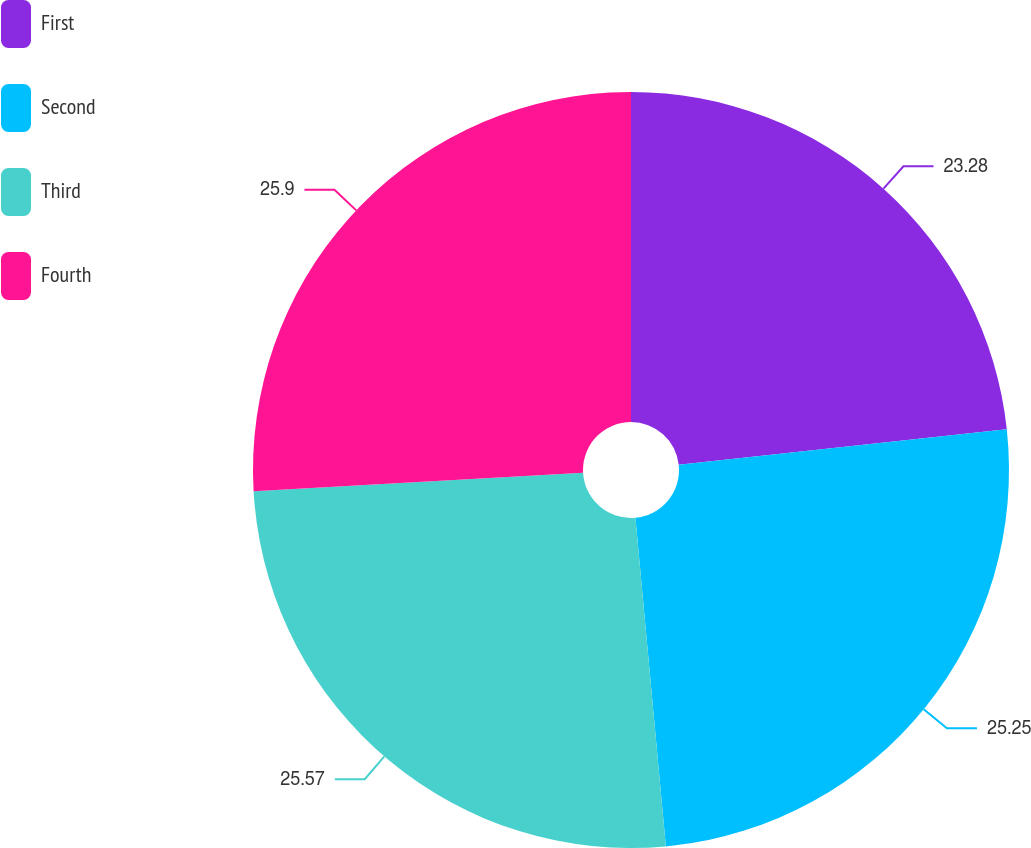Convert chart to OTSL. <chart><loc_0><loc_0><loc_500><loc_500><pie_chart><fcel>First<fcel>Second<fcel>Third<fcel>Fourth<nl><fcel>23.28%<fcel>25.25%<fcel>25.57%<fcel>25.9%<nl></chart> 